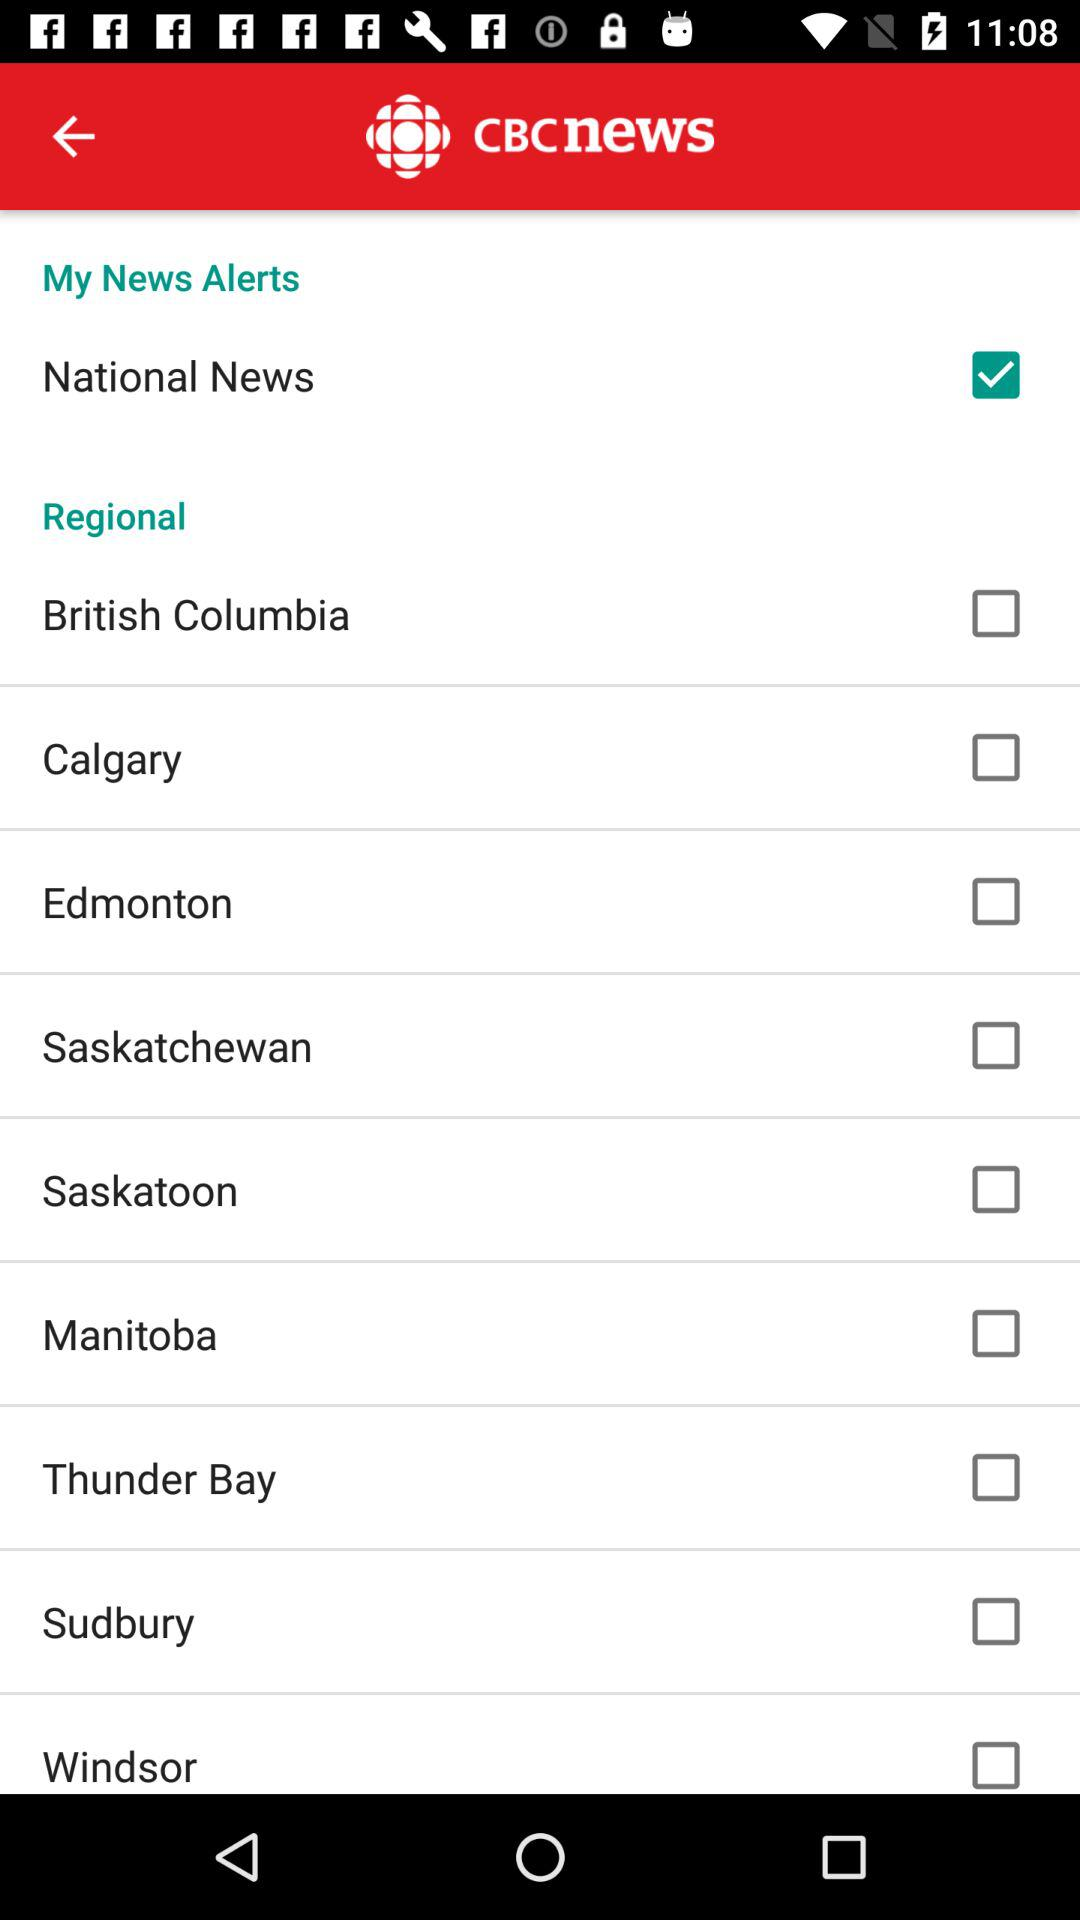Which is the checked checkbox? The checked checkbox is "National News". 